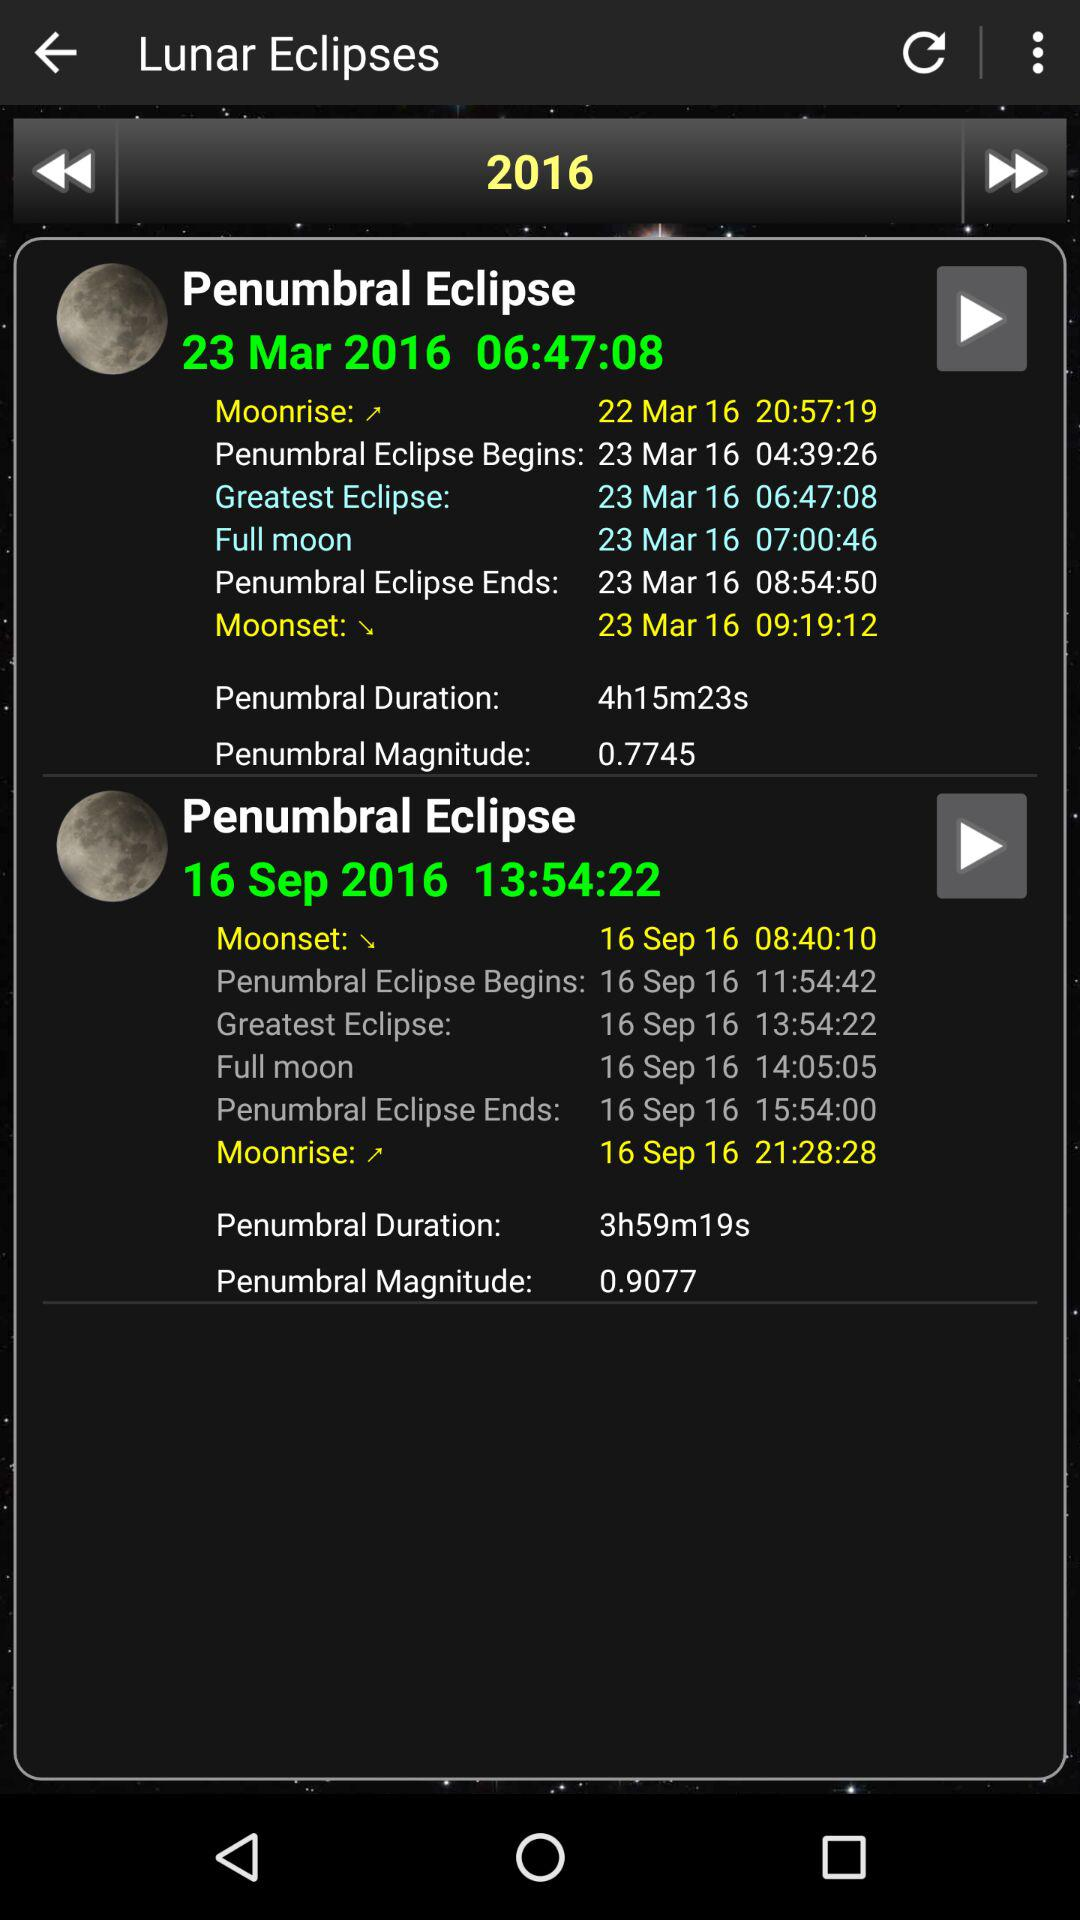On what dates did the penumbral eclipse happen? The dates are 23 Mar 2016 and 16 Sep 2016. 